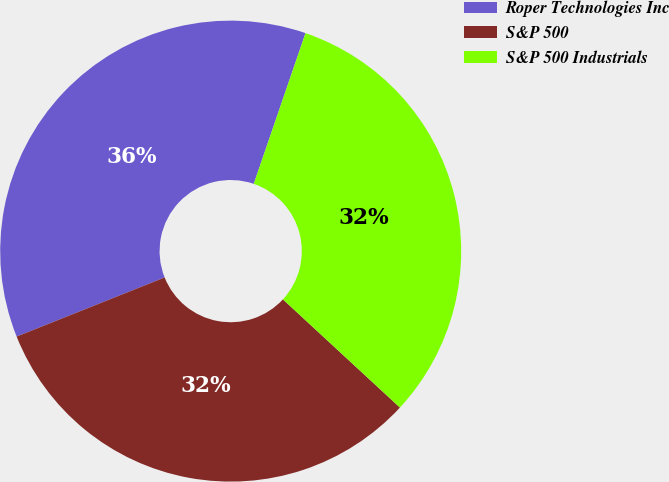Convert chart to OTSL. <chart><loc_0><loc_0><loc_500><loc_500><pie_chart><fcel>Roper Technologies Inc<fcel>S&P 500<fcel>S&P 500 Industrials<nl><fcel>36.31%<fcel>32.08%<fcel>31.61%<nl></chart> 